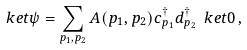Convert formula to latex. <formula><loc_0><loc_0><loc_500><loc_500>\ k e t \psi = \sum _ { p _ { 1 } , p _ { 2 } } A ( p _ { 1 } , p _ { 2 } ) c _ { p _ { 1 } } ^ { \dagger } d _ { p _ { 2 } } ^ { \dagger } \ k e t 0 \, ,</formula> 